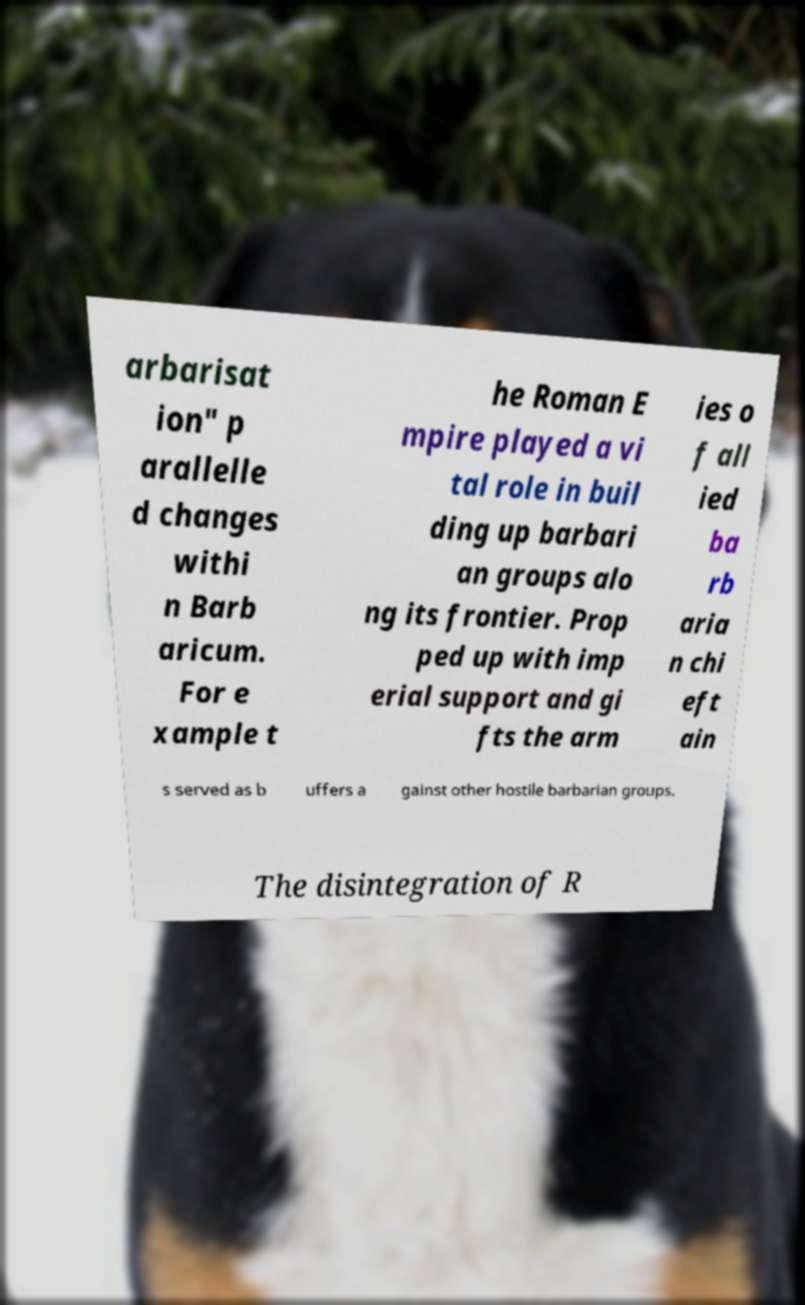What messages or text are displayed in this image? I need them in a readable, typed format. arbarisat ion" p arallelle d changes withi n Barb aricum. For e xample t he Roman E mpire played a vi tal role in buil ding up barbari an groups alo ng its frontier. Prop ped up with imp erial support and gi fts the arm ies o f all ied ba rb aria n chi eft ain s served as b uffers a gainst other hostile barbarian groups. The disintegration of R 